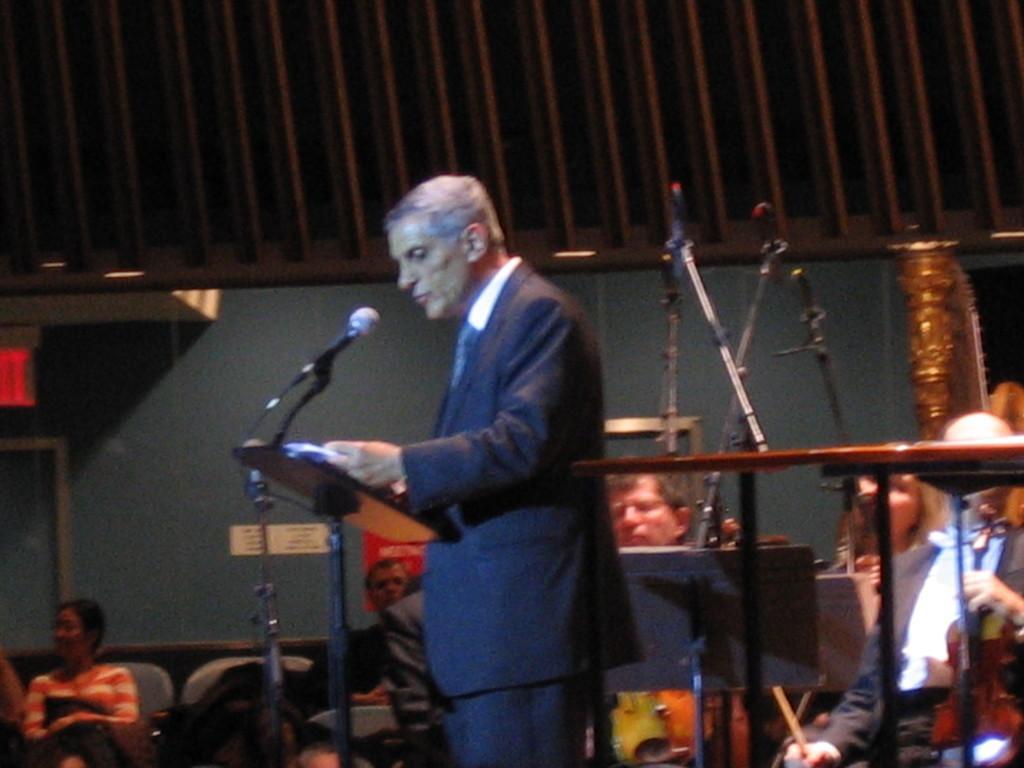Describe this image in one or two sentences. In this picture we can see a man is standing in front of a podium, there is a microphone in front of him, in the background there are some people sitting on chairs, on the right side there is a table and microphones. 